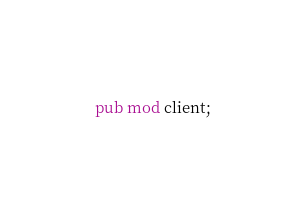<code> <loc_0><loc_0><loc_500><loc_500><_Rust_>pub mod client;</code> 